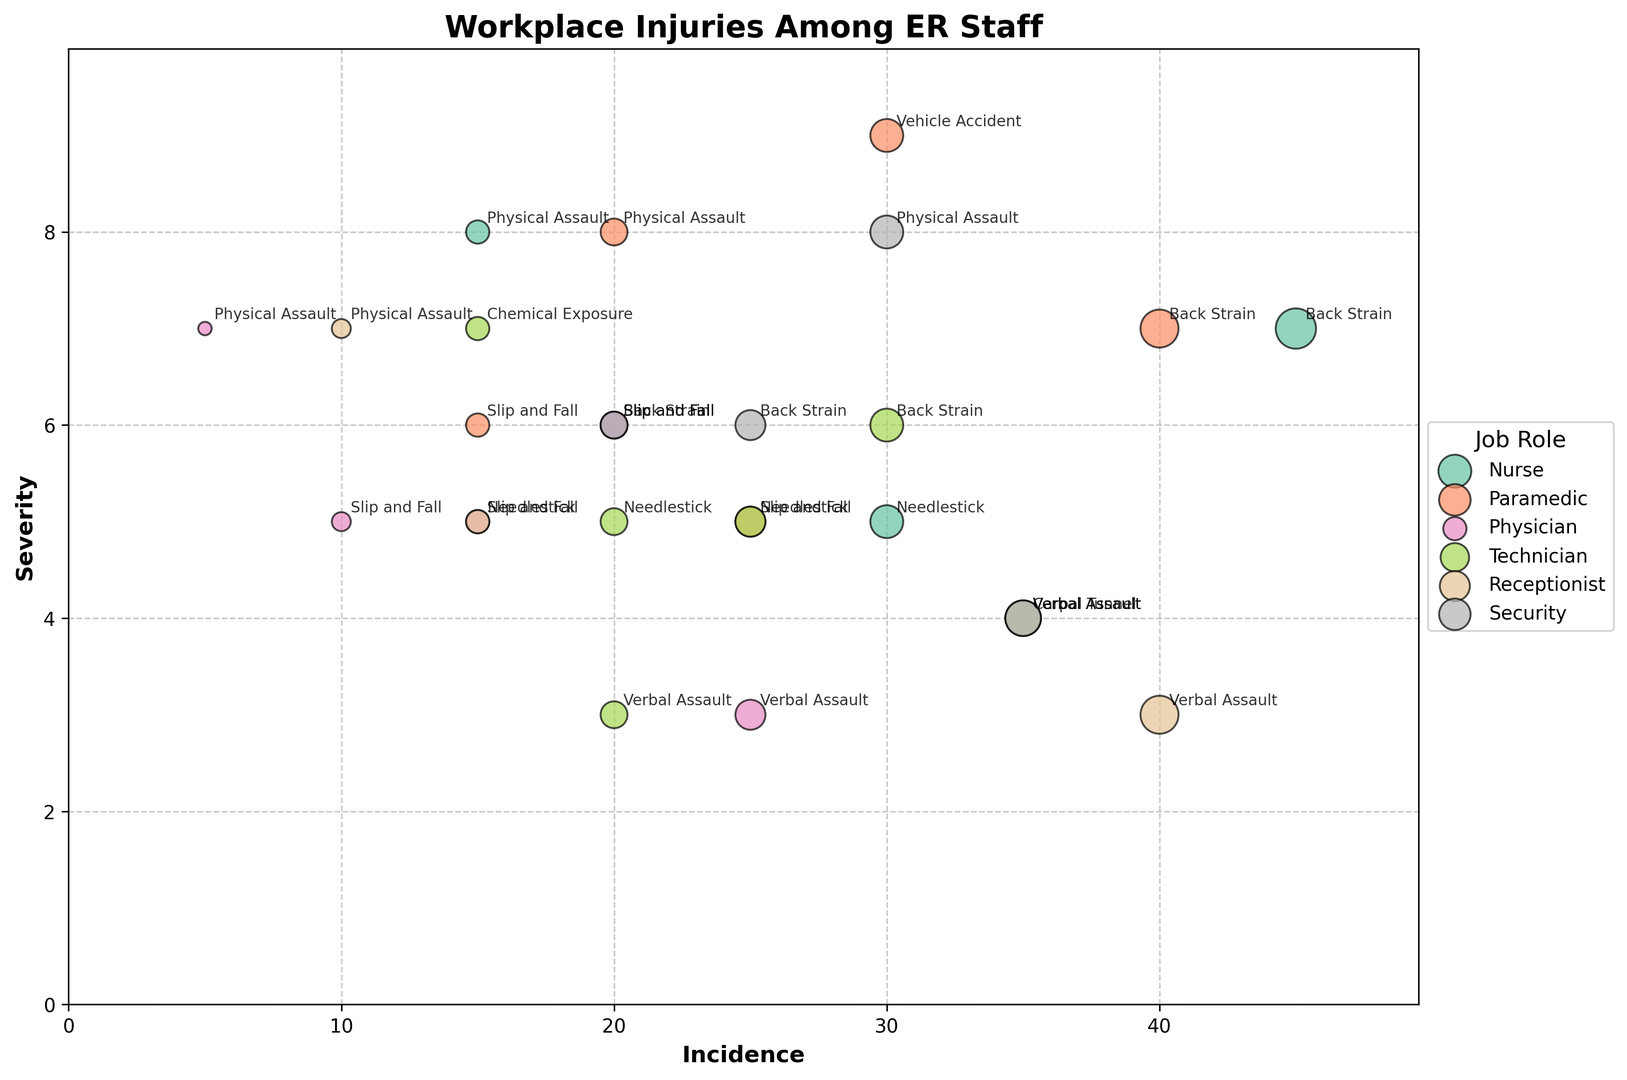Which job role has the highest incidence of physical assaults? The figure shows different bubble sizes representing incidence rates. By comparing the sizes of bubbles labeled "Physical Assault" across various job roles, we see that Security has the largest bubble indicating the highest incidence.
Answer: Security Which injury type has the highest severity among nurses? The visual attribute to consider here is the position on the Y-axis, which represents severity. For nurses, the bubble labeled "Physical Assault" is positioned highest on the Y-axis.
Answer: Physical Assault Compare the incidence of needlestick injuries between nurses and paramedics. Who has higher incidence? Incidence is represented by the size of the bubbles. For needlestick injuries, the nurse's bubble appears larger than the paramedic's bubble.
Answer: Nurse What is the total incidence of back strain across all job roles? Sum the incidence values of back strains for all job roles: Nurse (45) + Paramedic (40) + Physician (20) + Technician (30) + Security (25). The total is 160.
Answer: 160 Which job role has the lowest severity for verbal assaults? The bubble lowest on the Y-axis for "Verbal Assault" should be identified. The Physician has the lowest bubble in terms of Verbal Assault severity.
Answer: Physician Which injury types do receptionists experience, and which one is the most severe? Receptionists have bubbles labeled "Carpal Tunnel," "Slip and Fall," "Verbal Assault," and "Physical Assault." Among these, "Physical Assault" is highest on the Y-axis indicating the greatest severity.
Answer: Carpal Tunnel, Slip and Fall, Verbal Assault, Physical Assault; Physical Assault For paramedics, what is the difference in severity between vehicle accidents and needlestick injuries? Locate the position on the Y-axis for both "Vehicle Accident" and "Needlestick" for paramedics. The severity for vehicle accidents is 9, and for needlestick injuries, it is 5. Therefore, the difference is 4.
Answer: 4 What is the most common injury type among technicians, based on incidence? Compare the bubble sizes for different injury types among technicians. The bubble for "Slip and Fall" is largest, indicating the highest incidence.
Answer: Slip and Fall How does the incidence of verbal assaults compare between nurses and receptionists? Look at the size of the bubbles for "Verbal Assault." Nurses have an incidence of 35, and receptionists have an incidence of 40. Receptionists have a higher incidence.
Answer: Receptionists have a higher incidence Which job role experiences the least amount of slip and fall injuries? Identify the smallest bubble labeled "Slip and Fall" among the job roles. Physicians have the smallest bubble for slip and fall injuries with an incidence of 10.
Answer: Physician 